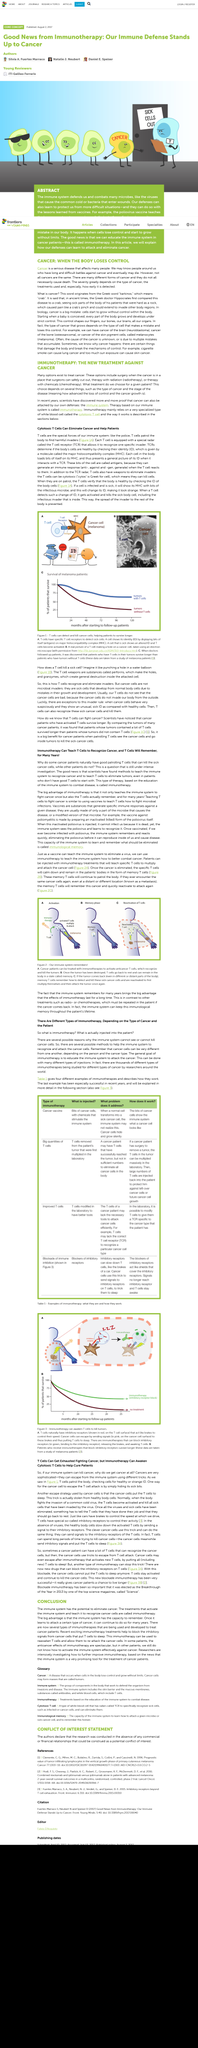Indicate a few pertinent items in this graphic. The immune system is unable to detect or destroy cancer cells on its own. However, immunotherapy can assist the immune system in recognizing and attacking cancer cells, making it a valuable tool in the fight against cancer. There are indeed many forms of cancer. Cancer is a serious disease that affects many people, causing cells in the body to grow out of control and form tumors. Yes, people can eventually die from cancer. The new treatment relies on cytotoxic T cells. 